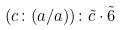Convert formula to latex. <formula><loc_0><loc_0><loc_500><loc_500>( c \colon ( a / a ) ) \colon \tilde { c } \cdot \tilde { 6 }</formula> 